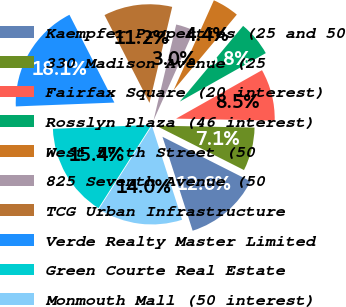Convert chart. <chart><loc_0><loc_0><loc_500><loc_500><pie_chart><fcel>Kaempfer Properties (25 and 50<fcel>330 Madison Avenue (25<fcel>Fairfax Square (20 interest)<fcel>Rosslyn Plaza (46 interest)<fcel>West 57^th Street (50<fcel>825 Seventh Avenue (50<fcel>TCG Urban Infrastructure<fcel>Verde Realty Master Limited<fcel>Green Courte Real Estate<fcel>Monmouth Mall (50 interest)<nl><fcel>12.61%<fcel>7.12%<fcel>8.49%<fcel>5.75%<fcel>4.38%<fcel>3.0%<fcel>11.23%<fcel>18.09%<fcel>15.35%<fcel>13.98%<nl></chart> 